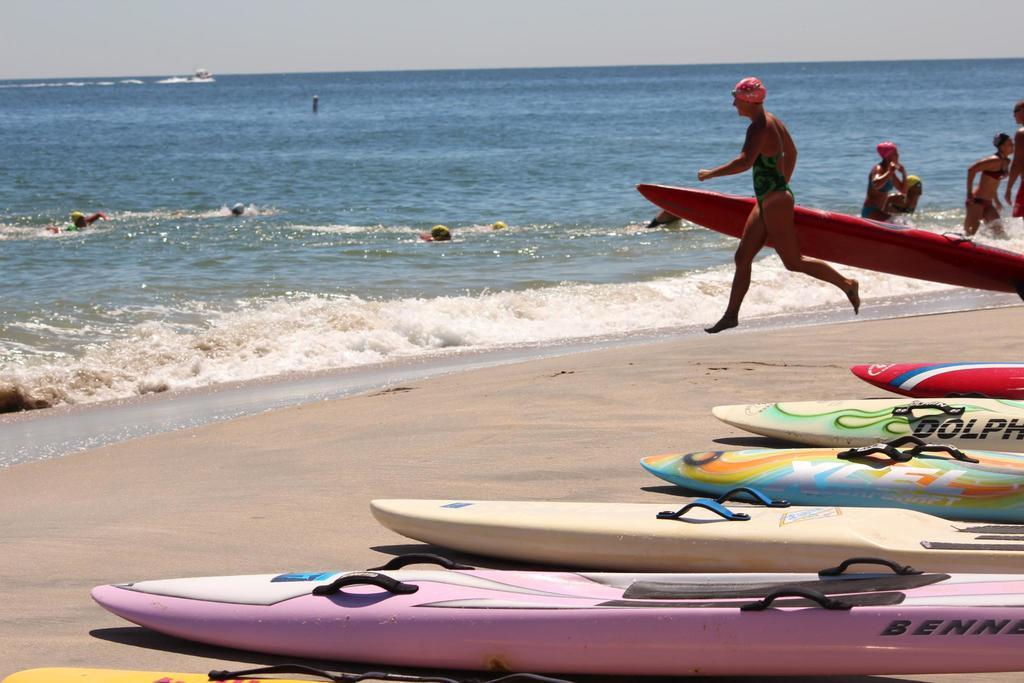Provide a one-sentence caption for the provided image. Surfboards lie in a row on a beach, one of them with part of the word Dolphin on it. 